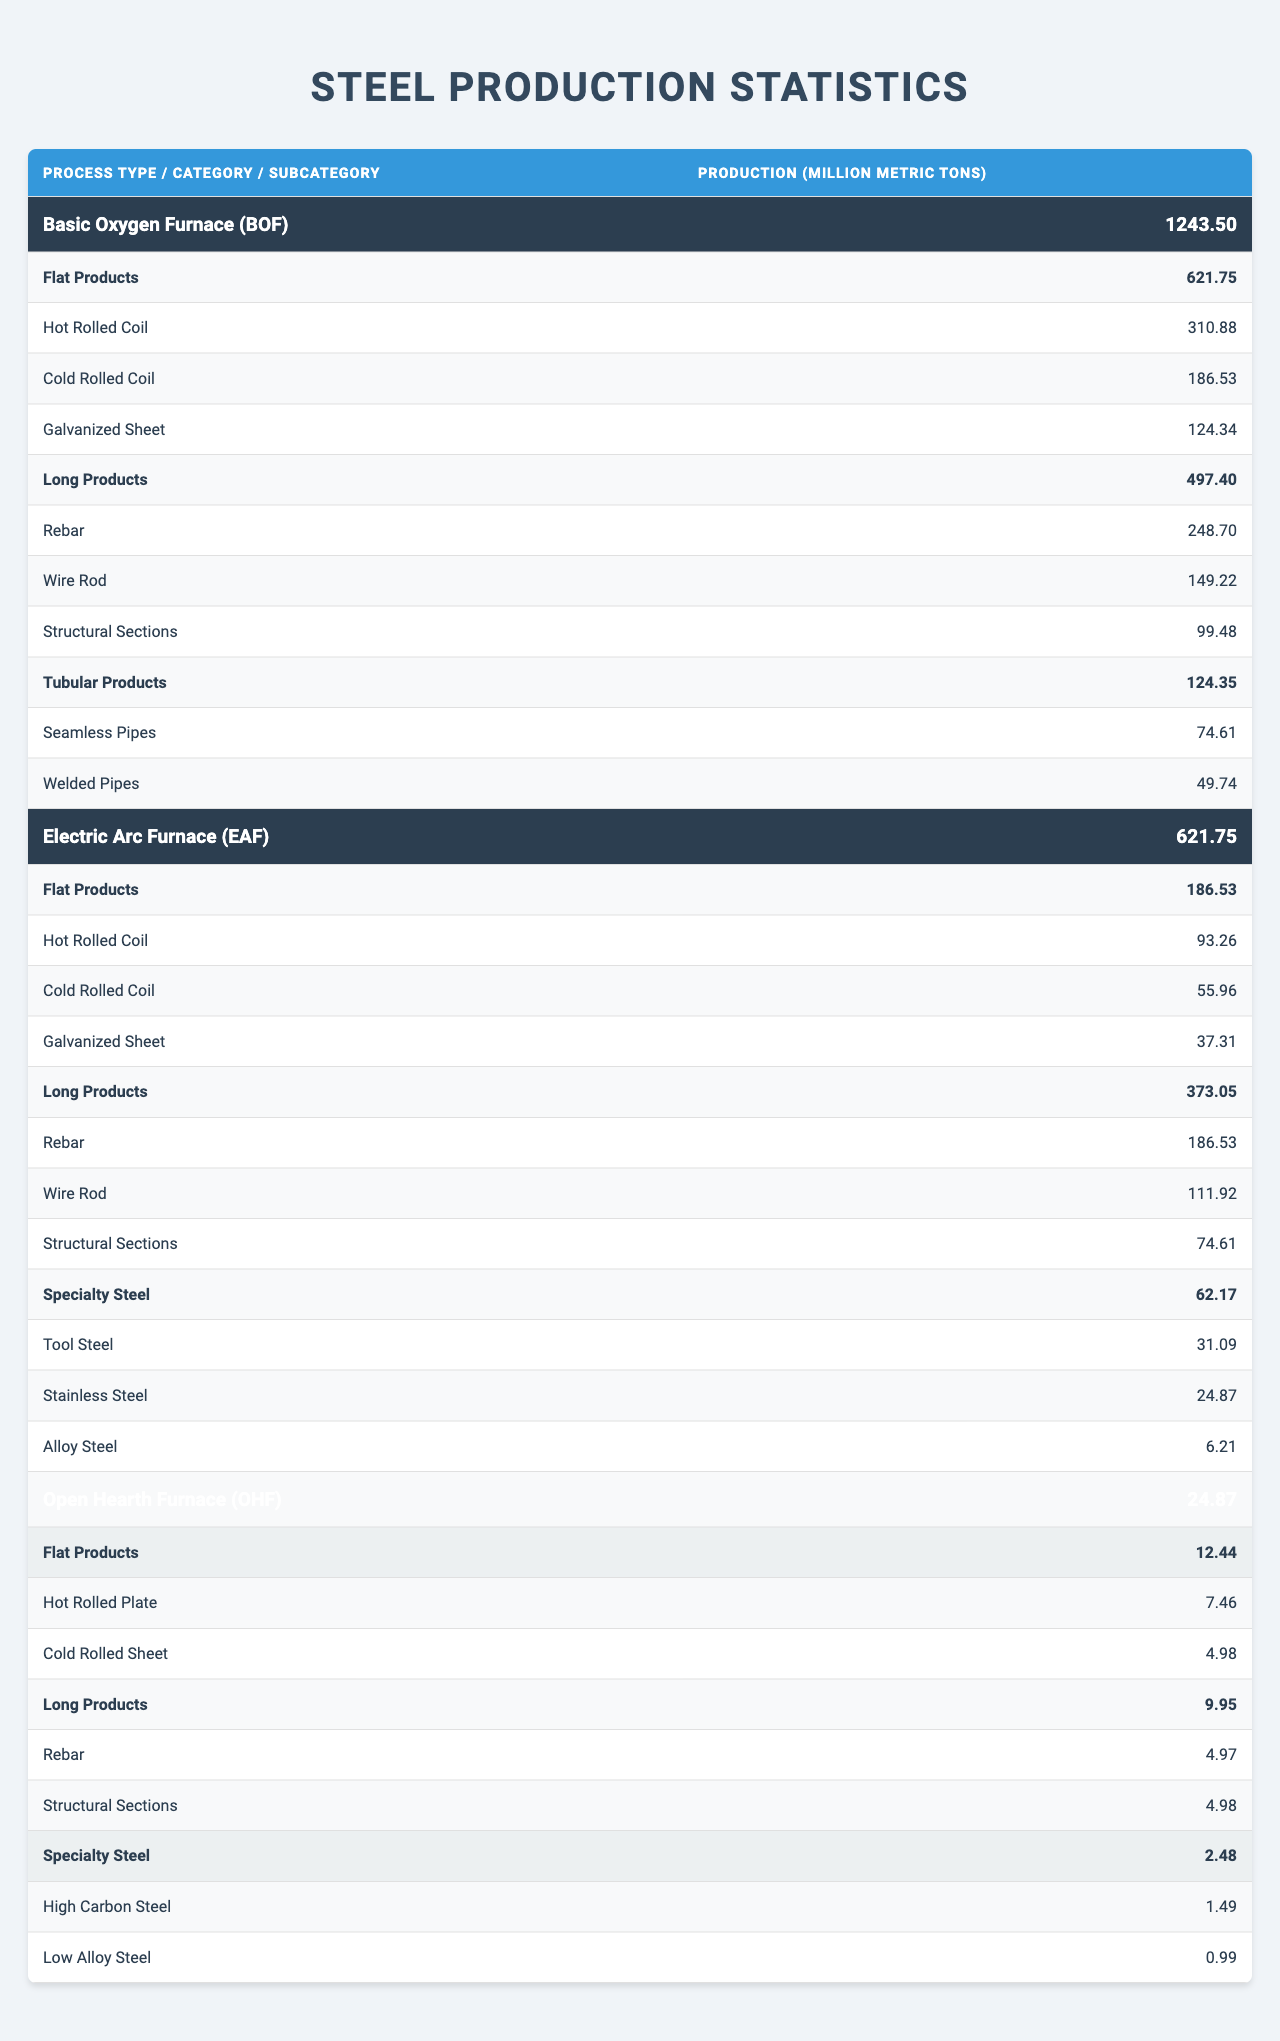What's the total production of steel from the Basic Oxygen Furnace? The total production for the Basic Oxygen Furnace is listed in the table under "Total Production (million metric tons)" as 1243.5.
Answer: 1243.5 million metric tons Which product category has the highest production from the Electric Arc Furnace? The product categories under the Electric Arc Furnace are Flat Products, Long Products, and Specialty Steel. Long Products have the highest production at 373.05 million metric tons.
Answer: Long Products How much production is in the Flat Products category from the Open Hearth Furnace? The Open Hearth Furnace's Flat Products category shows a production of 12.44 million metric tons.
Answer: 12.44 million metric tons What is the total production of Long Products across all processes? The total production of Long Products is calculated by summing the Long Products from each process: 497.4 (BOF) + 373.05 (EAF) + 9.95 (OHF) = 880.4 million metric tons.
Answer: 880.4 million metric tons Is the production of Cold Rolled Coil from the Basic Oxygen Furnace higher than from the Electric Arc Furnace? The Cold Rolled Coil production is 186.53 million metric tons from BOF and 55.96 million metric tons from EAF. Since 186.53 is greater than 55.96, the statement is true.
Answer: Yes How many subcategories are there under Long Products in the Electric Arc Furnace? The Electric Arc Furnace has three subcategories listed under Long Products: Rebar, Wire Rod, and Structural Sections. Counting them gives us three subcategories.
Answer: 3 What percentage of the total production from the Basic Oxygen Furnace is Flat Products? Total production from BOF is 1243.5 million metric tons, and Flat Products production is 621.75 million metric tons. The percentage is calculated as (621.75 / 1243.5) * 100 = 50%.
Answer: 50% If we combine the production of Seamless Pipes and Welded Pipes, how does that compare to the production of Cold Rolled Coil from the Basic Oxygen Furnace? The combined production of Seamless Pipes (74.61 million metric tons) and Welded Pipes (49.74 million metric tons) is 124.35 million metric tons. The Cold Rolled Coil production from BOF is 186.53 million metric tons. Since 124.35 is less than 186.53, the combined production is less.
Answer: Less What is the total production of Specialty Steel across all processes? Summing the Specialty Steel production from each process: 62.17 (EAF) + 2.48 (OHF) = 64.65 million metric tons. OHF has no Specialty Steel listed in BOF.
Answer: 64.65 million metric tons Is the production of Hot Rolled Coil from the Electric Arc Furnace less than half of the production in the Basic Oxygen Furnace? The production of Hot Rolled Coil is 93.26 million metric tons from EAF and 310.88 million metric tons from BOF. Half of BOF's production would be 155.44 million metric tons. Since 93.26 is less than 155.44, the statement is true.
Answer: Yes 